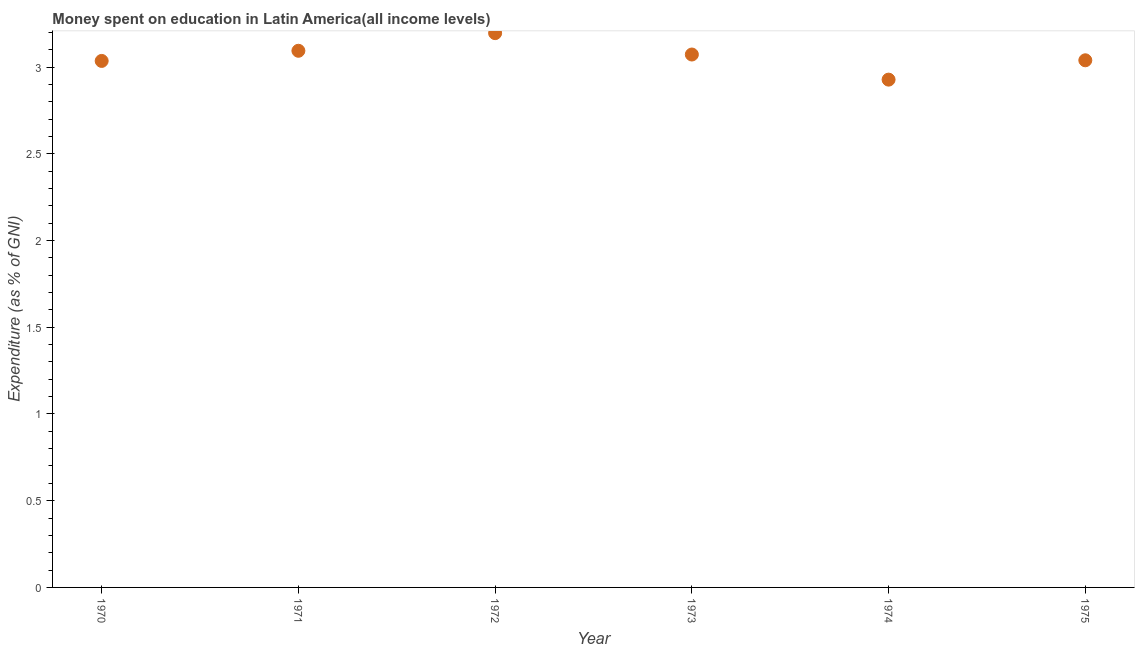What is the expenditure on education in 1973?
Offer a very short reply. 3.07. Across all years, what is the maximum expenditure on education?
Offer a very short reply. 3.2. Across all years, what is the minimum expenditure on education?
Provide a succinct answer. 2.93. In which year was the expenditure on education minimum?
Provide a succinct answer. 1974. What is the sum of the expenditure on education?
Give a very brief answer. 18.36. What is the difference between the expenditure on education in 1970 and 1974?
Ensure brevity in your answer.  0.11. What is the average expenditure on education per year?
Ensure brevity in your answer.  3.06. What is the median expenditure on education?
Provide a short and direct response. 3.06. In how many years, is the expenditure on education greater than 3.1 %?
Your response must be concise. 1. What is the ratio of the expenditure on education in 1973 to that in 1974?
Keep it short and to the point. 1.05. Is the expenditure on education in 1971 less than that in 1973?
Offer a very short reply. No. Is the difference between the expenditure on education in 1974 and 1975 greater than the difference between any two years?
Your answer should be very brief. No. What is the difference between the highest and the second highest expenditure on education?
Your answer should be compact. 0.1. What is the difference between the highest and the lowest expenditure on education?
Your answer should be compact. 0.27. In how many years, is the expenditure on education greater than the average expenditure on education taken over all years?
Give a very brief answer. 3. What is the title of the graph?
Offer a very short reply. Money spent on education in Latin America(all income levels). What is the label or title of the Y-axis?
Your answer should be compact. Expenditure (as % of GNI). What is the Expenditure (as % of GNI) in 1970?
Make the answer very short. 3.04. What is the Expenditure (as % of GNI) in 1971?
Your answer should be very brief. 3.09. What is the Expenditure (as % of GNI) in 1972?
Give a very brief answer. 3.2. What is the Expenditure (as % of GNI) in 1973?
Provide a short and direct response. 3.07. What is the Expenditure (as % of GNI) in 1974?
Provide a short and direct response. 2.93. What is the Expenditure (as % of GNI) in 1975?
Offer a very short reply. 3.04. What is the difference between the Expenditure (as % of GNI) in 1970 and 1971?
Your answer should be very brief. -0.06. What is the difference between the Expenditure (as % of GNI) in 1970 and 1972?
Offer a very short reply. -0.16. What is the difference between the Expenditure (as % of GNI) in 1970 and 1973?
Keep it short and to the point. -0.04. What is the difference between the Expenditure (as % of GNI) in 1970 and 1974?
Provide a succinct answer. 0.11. What is the difference between the Expenditure (as % of GNI) in 1970 and 1975?
Make the answer very short. -0. What is the difference between the Expenditure (as % of GNI) in 1971 and 1972?
Provide a succinct answer. -0.1. What is the difference between the Expenditure (as % of GNI) in 1971 and 1973?
Provide a short and direct response. 0.02. What is the difference between the Expenditure (as % of GNI) in 1971 and 1974?
Your answer should be compact. 0.17. What is the difference between the Expenditure (as % of GNI) in 1971 and 1975?
Your response must be concise. 0.05. What is the difference between the Expenditure (as % of GNI) in 1972 and 1973?
Provide a short and direct response. 0.12. What is the difference between the Expenditure (as % of GNI) in 1972 and 1974?
Give a very brief answer. 0.27. What is the difference between the Expenditure (as % of GNI) in 1972 and 1975?
Your response must be concise. 0.16. What is the difference between the Expenditure (as % of GNI) in 1973 and 1974?
Offer a very short reply. 0.14. What is the difference between the Expenditure (as % of GNI) in 1973 and 1975?
Ensure brevity in your answer.  0.03. What is the difference between the Expenditure (as % of GNI) in 1974 and 1975?
Offer a terse response. -0.11. What is the ratio of the Expenditure (as % of GNI) in 1970 to that in 1973?
Ensure brevity in your answer.  0.99. What is the ratio of the Expenditure (as % of GNI) in 1970 to that in 1975?
Ensure brevity in your answer.  1. What is the ratio of the Expenditure (as % of GNI) in 1971 to that in 1973?
Offer a very short reply. 1.01. What is the ratio of the Expenditure (as % of GNI) in 1971 to that in 1974?
Offer a terse response. 1.06. What is the ratio of the Expenditure (as % of GNI) in 1971 to that in 1975?
Ensure brevity in your answer.  1.02. What is the ratio of the Expenditure (as % of GNI) in 1972 to that in 1974?
Provide a short and direct response. 1.09. What is the ratio of the Expenditure (as % of GNI) in 1972 to that in 1975?
Provide a short and direct response. 1.05. What is the ratio of the Expenditure (as % of GNI) in 1973 to that in 1974?
Offer a very short reply. 1.05. What is the ratio of the Expenditure (as % of GNI) in 1973 to that in 1975?
Your answer should be compact. 1.01. 